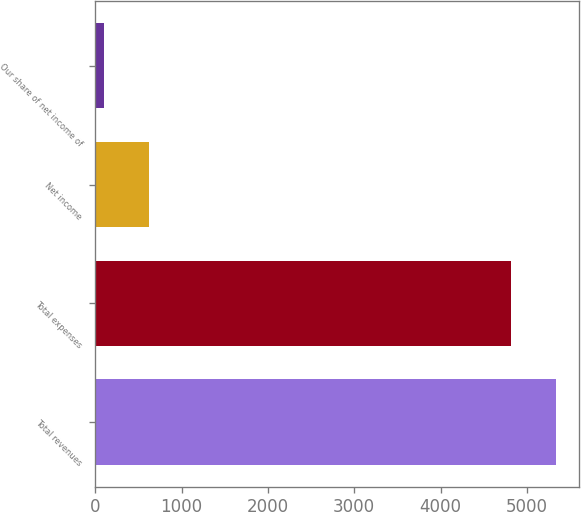<chart> <loc_0><loc_0><loc_500><loc_500><bar_chart><fcel>Total revenues<fcel>Total expenses<fcel>Net income<fcel>Our share of net income of<nl><fcel>5334.93<fcel>4812.3<fcel>622.53<fcel>99.9<nl></chart> 